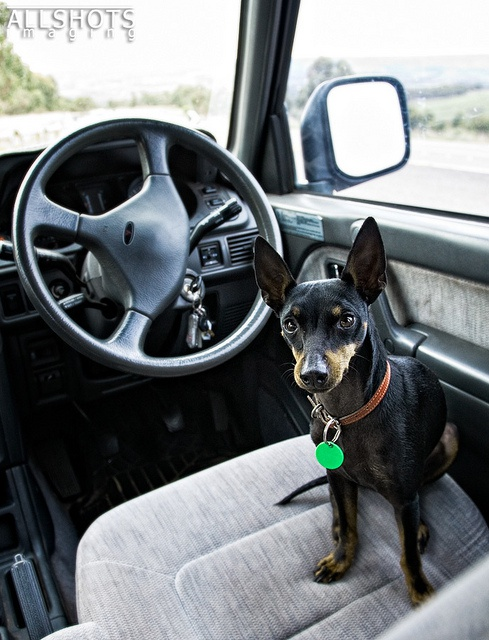Describe the objects in this image and their specific colors. I can see a dog in white, black, gray, and darkblue tones in this image. 